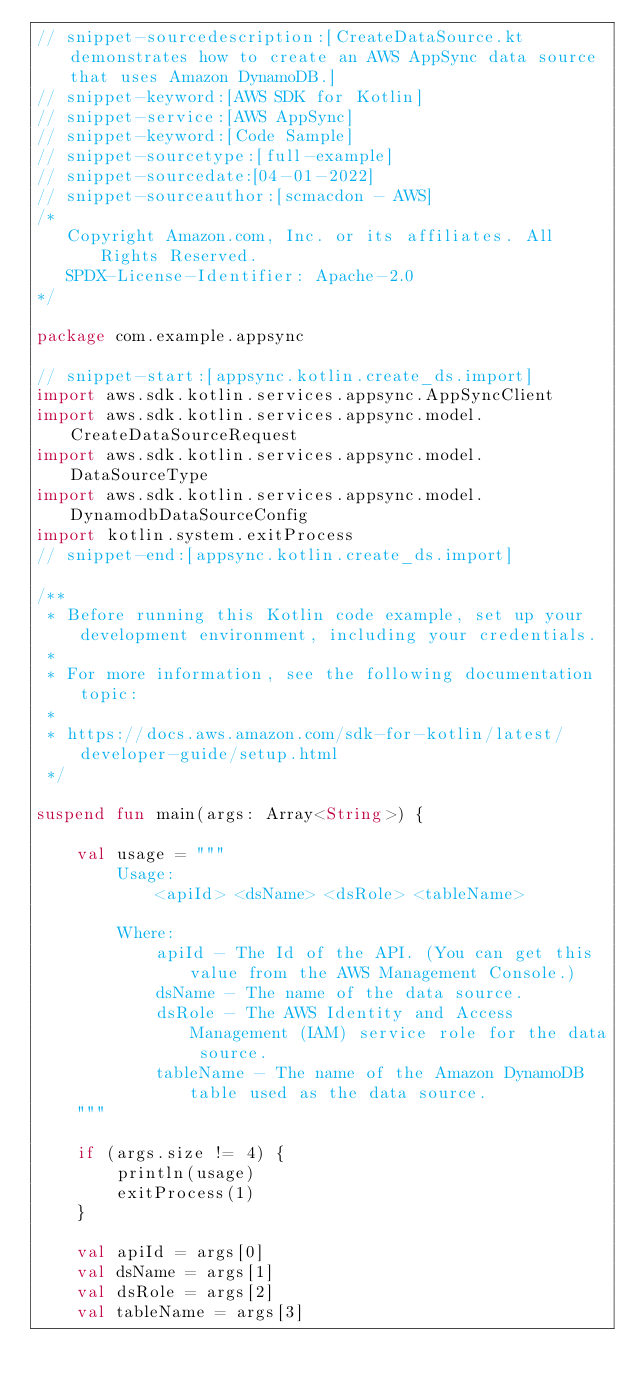<code> <loc_0><loc_0><loc_500><loc_500><_Kotlin_>// snippet-sourcedescription:[CreateDataSource.kt demonstrates how to create an AWS AppSync data source that uses Amazon DynamoDB.]
// snippet-keyword:[AWS SDK for Kotlin]
// snippet-service:[AWS AppSync]
// snippet-keyword:[Code Sample]
// snippet-sourcetype:[full-example]
// snippet-sourcedate:[04-01-2022]
// snippet-sourceauthor:[scmacdon - AWS]
/*
   Copyright Amazon.com, Inc. or its affiliates. All Rights Reserved.
   SPDX-License-Identifier: Apache-2.0
*/

package com.example.appsync

// snippet-start:[appsync.kotlin.create_ds.import]
import aws.sdk.kotlin.services.appsync.AppSyncClient
import aws.sdk.kotlin.services.appsync.model.CreateDataSourceRequest
import aws.sdk.kotlin.services.appsync.model.DataSourceType
import aws.sdk.kotlin.services.appsync.model.DynamodbDataSourceConfig
import kotlin.system.exitProcess
// snippet-end:[appsync.kotlin.create_ds.import]

/**
 * Before running this Kotlin code example, set up your development environment, including your credentials.
 *
 * For more information, see the following documentation topic:
 *
 * https://docs.aws.amazon.com/sdk-for-kotlin/latest/developer-guide/setup.html
 */

suspend fun main(args: Array<String>) {

    val usage = """
        Usage:
            <apiId> <dsName> <dsRole> <tableName>

        Where:
            apiId - The Id of the API. (You can get this value from the AWS Management Console.)
            dsName - The name of the data source. 
            dsRole - The AWS Identity and Access Management (IAM) service role for the data source. 
            tableName - The name of the Amazon DynamoDB table used as the data source.
    """

    if (args.size != 4) {
        println(usage)
        exitProcess(1)
    }

    val apiId = args[0]
    val dsName = args[1]
    val dsRole = args[2]
    val tableName = args[3]</code> 